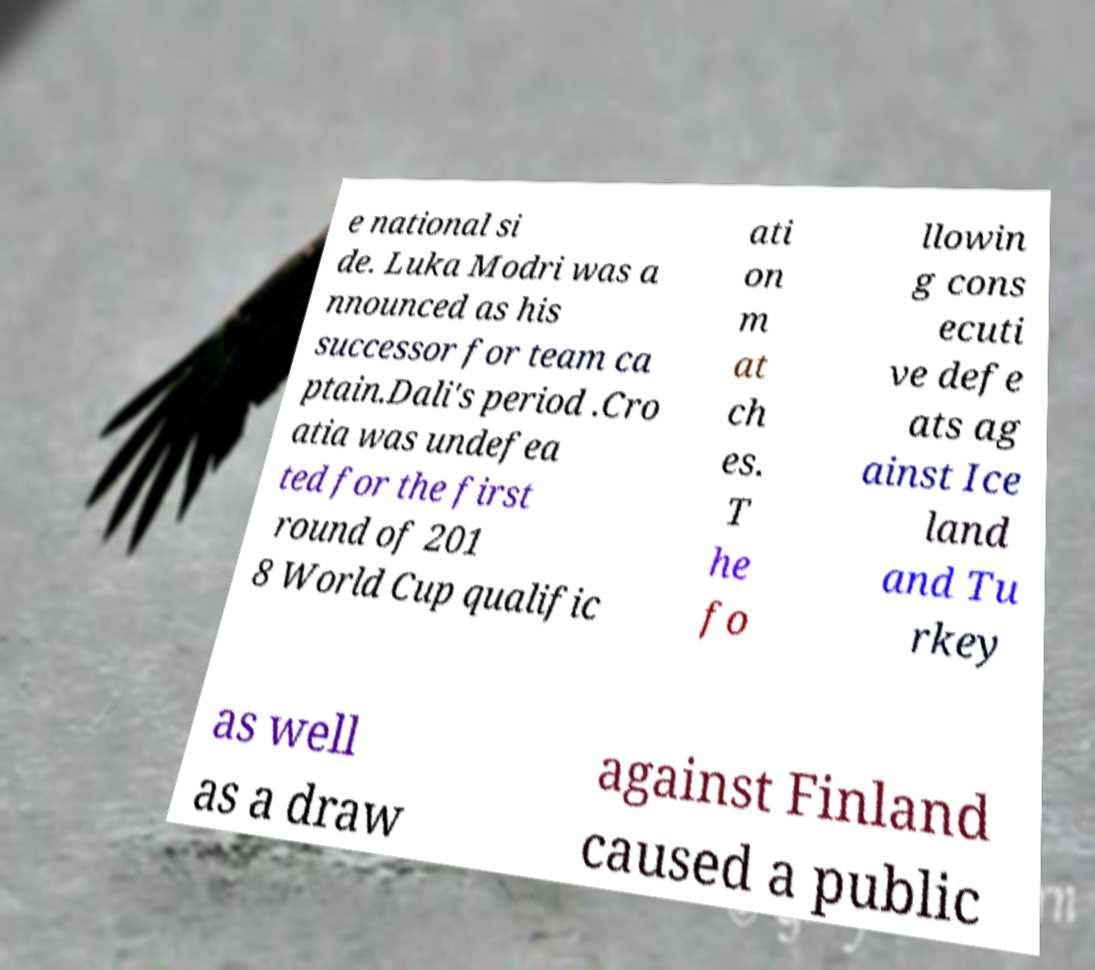Can you accurately transcribe the text from the provided image for me? e national si de. Luka Modri was a nnounced as his successor for team ca ptain.Dali's period .Cro atia was undefea ted for the first round of 201 8 World Cup qualific ati on m at ch es. T he fo llowin g cons ecuti ve defe ats ag ainst Ice land and Tu rkey as well as a draw against Finland caused a public 